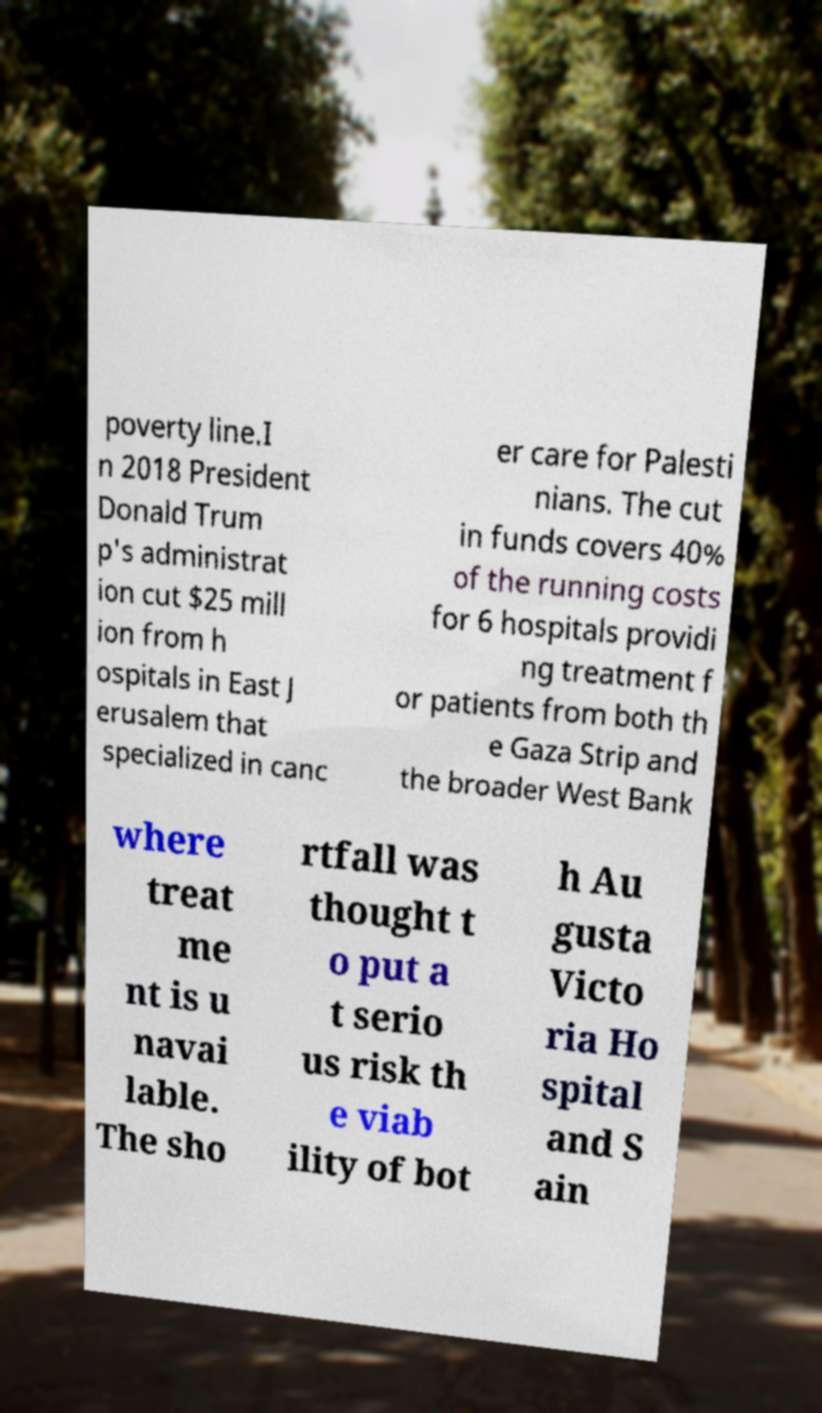Can you accurately transcribe the text from the provided image for me? poverty line.I n 2018 President Donald Trum p's administrat ion cut $25 mill ion from h ospitals in East J erusalem that specialized in canc er care for Palesti nians. The cut in funds covers 40% of the running costs for 6 hospitals providi ng treatment f or patients from both th e Gaza Strip and the broader West Bank where treat me nt is u navai lable. The sho rtfall was thought t o put a t serio us risk th e viab ility of bot h Au gusta Victo ria Ho spital and S ain 